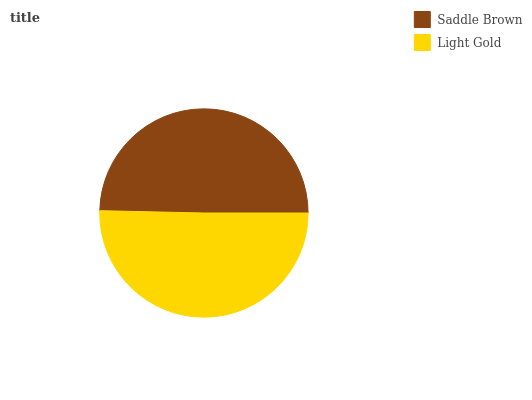Is Saddle Brown the minimum?
Answer yes or no. Yes. Is Light Gold the maximum?
Answer yes or no. Yes. Is Light Gold the minimum?
Answer yes or no. No. Is Light Gold greater than Saddle Brown?
Answer yes or no. Yes. Is Saddle Brown less than Light Gold?
Answer yes or no. Yes. Is Saddle Brown greater than Light Gold?
Answer yes or no. No. Is Light Gold less than Saddle Brown?
Answer yes or no. No. Is Light Gold the high median?
Answer yes or no. Yes. Is Saddle Brown the low median?
Answer yes or no. Yes. Is Saddle Brown the high median?
Answer yes or no. No. Is Light Gold the low median?
Answer yes or no. No. 